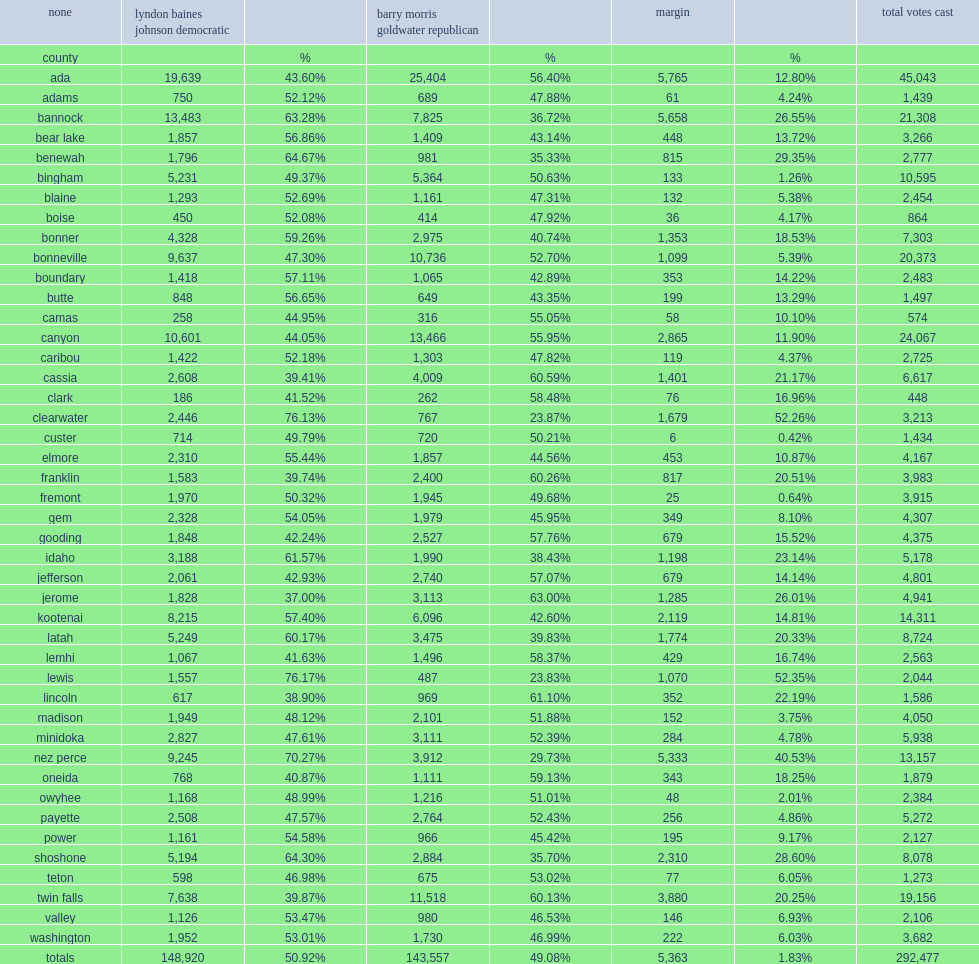What was the number of margin votes totally? 5363.0. 